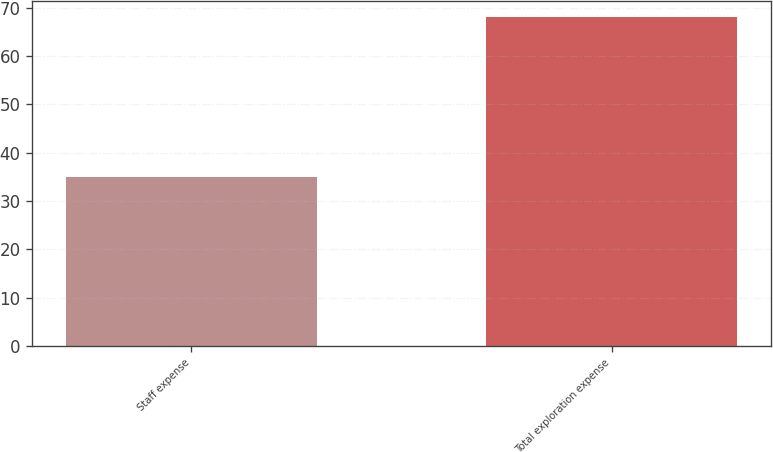Convert chart to OTSL. <chart><loc_0><loc_0><loc_500><loc_500><bar_chart><fcel>Staff expense<fcel>Total exploration expense<nl><fcel>35<fcel>68<nl></chart> 